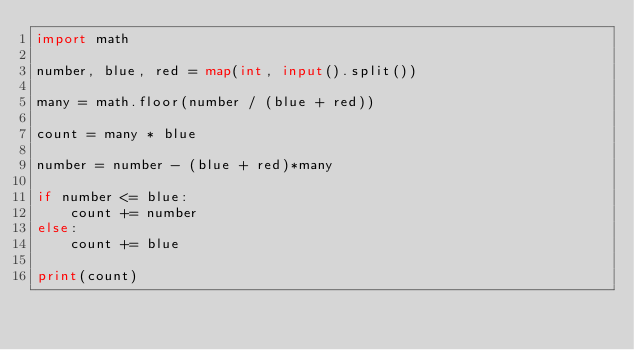<code> <loc_0><loc_0><loc_500><loc_500><_Python_>import math

number, blue, red = map(int, input().split())

many = math.floor(number / (blue + red))

count = many * blue

number = number - (blue + red)*many

if number <= blue:
    count += number
else:
    count += blue

print(count)</code> 